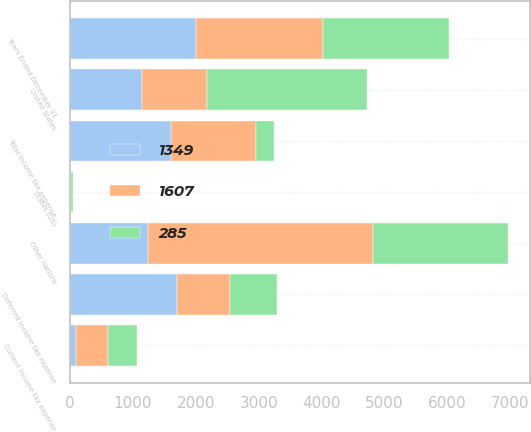Convert chart to OTSL. <chart><loc_0><loc_0><loc_500><loc_500><stacked_bar_chart><ecel><fcel>Years Ended December 31<fcel>United States<fcel>Other nations<fcel>States (US)<fcel>Current income tax expense<fcel>Deferred income tax expense<fcel>Total income tax expense<nl><fcel>1349<fcel>2008<fcel>1138.5<fcel>1243<fcel>5<fcel>91<fcel>1698<fcel>1607<nl><fcel>285<fcel>2007<fcel>2540<fcel>2150<fcel>20<fcel>462<fcel>747<fcel>285<nl><fcel>1607<fcel>2006<fcel>1034<fcel>3576<fcel>13<fcel>511<fcel>838<fcel>1349<nl></chart> 